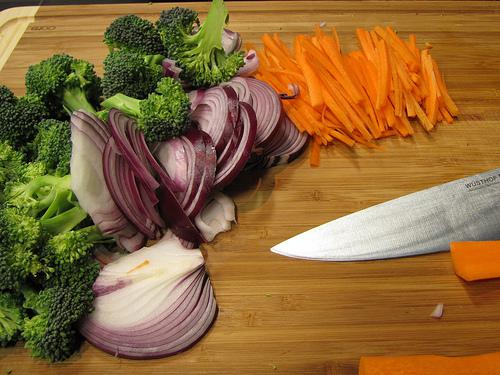Question: where was this picture likely taken?
Choices:
A. A bathroom.
B. A kitchen.
C. A den.
D. A bedroom.
Answer with the letter. Answer: B Question: what are the vegetables sitting on?
Choices:
A. A table.
B. A plate.
C. A cutting board.
D. A bowl.
Answer with the letter. Answer: C Question: what color is the onion?
Choices:
A. Red.
B. Yellow.
C. Purple.
D. White.
Answer with the letter. Answer: A Question: what company name is on the knife?
Choices:
A. Nielof.
B. Baliff.
C. Softof.
D. Wusthof.
Answer with the letter. Answer: D Question: how many vegetables are seen?
Choices:
A. Two.
B. Three.
C. Four.
D. Five.
Answer with the letter. Answer: B Question: what color is the vegetable on the left?
Choices:
A. Yellow.
B. Orange.
C. Red.
D. Green.
Answer with the letter. Answer: D Question: what material is the cutting board made of?
Choices:
A. Wood.
B. Plastic.
C. Glass.
D. Marble.
Answer with the letter. Answer: A 